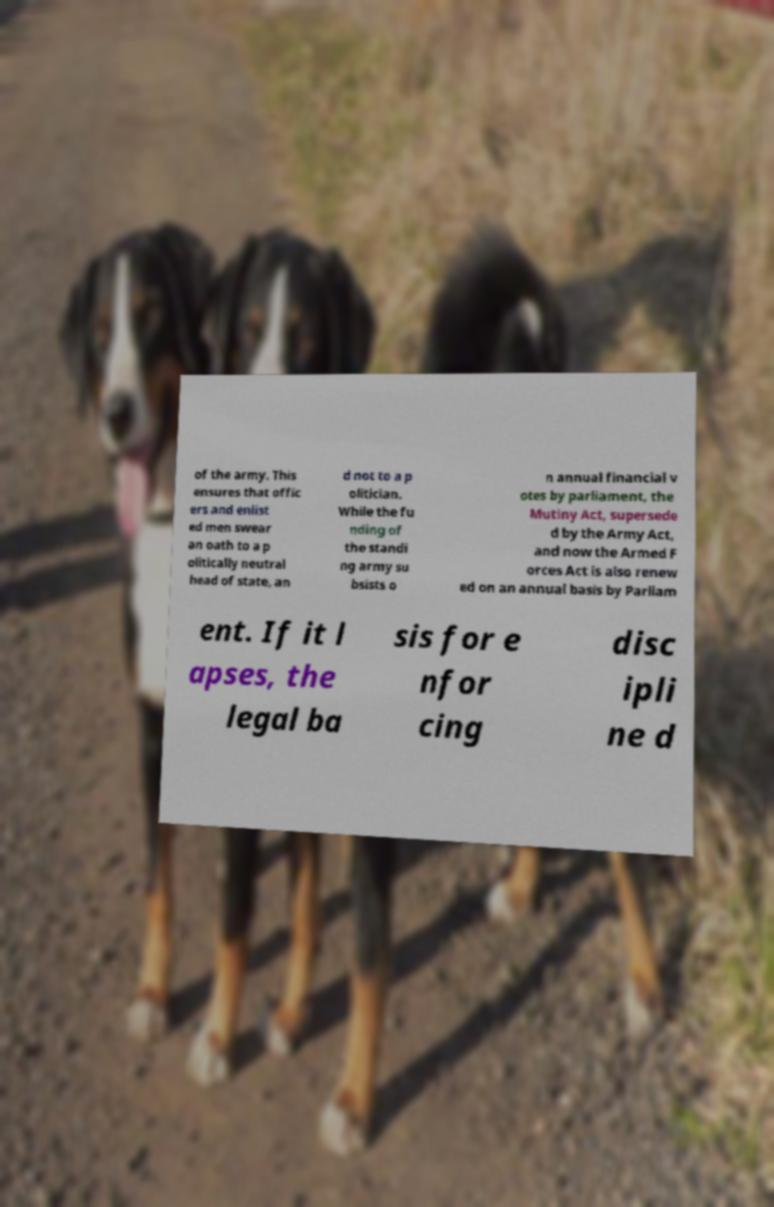I need the written content from this picture converted into text. Can you do that? of the army. This ensures that offic ers and enlist ed men swear an oath to a p olitically neutral head of state, an d not to a p olitician. While the fu nding of the standi ng army su bsists o n annual financial v otes by parliament, the Mutiny Act, supersede d by the Army Act, and now the Armed F orces Act is also renew ed on an annual basis by Parliam ent. If it l apses, the legal ba sis for e nfor cing disc ipli ne d 